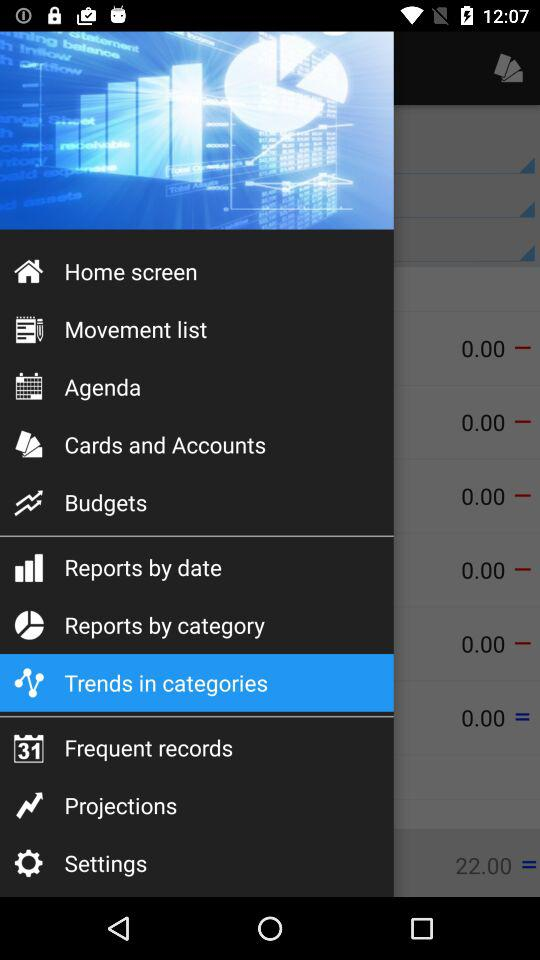Which item is selected in the menu? The selected item is "Trends in categories". 